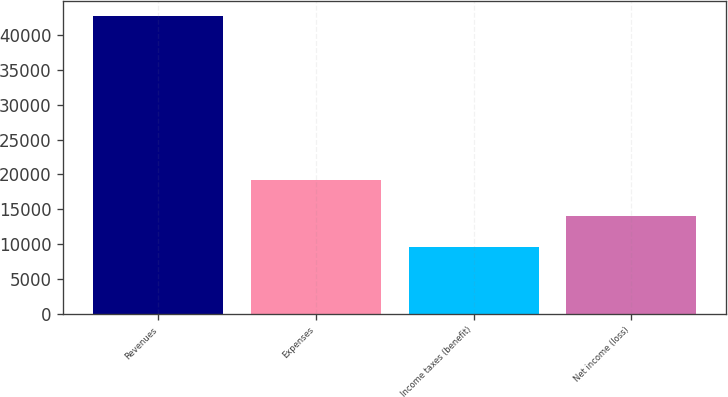Convert chart to OTSL. <chart><loc_0><loc_0><loc_500><loc_500><bar_chart><fcel>Revenues<fcel>Expenses<fcel>Income taxes (benefit)<fcel>Net income (loss)<nl><fcel>42738<fcel>19198<fcel>9578<fcel>13962<nl></chart> 